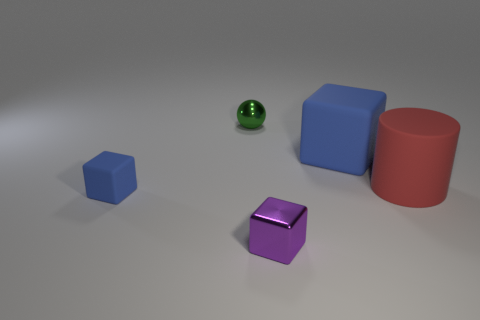What shape is the object that is behind the cylinder and on the left side of the tiny metallic cube?
Give a very brief answer. Sphere. What number of green metal balls are there?
Make the answer very short. 1. There is a thing that is the same color as the small matte cube; what is its shape?
Provide a succinct answer. Cube. There is a purple object that is the same shape as the large blue thing; what is its size?
Offer a terse response. Small. There is a blue object that is to the right of the small rubber cube; does it have the same shape as the green object?
Ensure brevity in your answer.  No. What is the color of the tiny cube on the right side of the tiny green metallic object?
Provide a succinct answer. Purple. What number of other objects are there of the same size as the purple metallic cube?
Give a very brief answer. 2. Are there any other things that have the same shape as the green metallic object?
Provide a short and direct response. No. Are there the same number of small rubber things in front of the purple shiny object and blue rubber things?
Offer a terse response. No. How many tiny balls have the same material as the big blue object?
Offer a terse response. 0. 